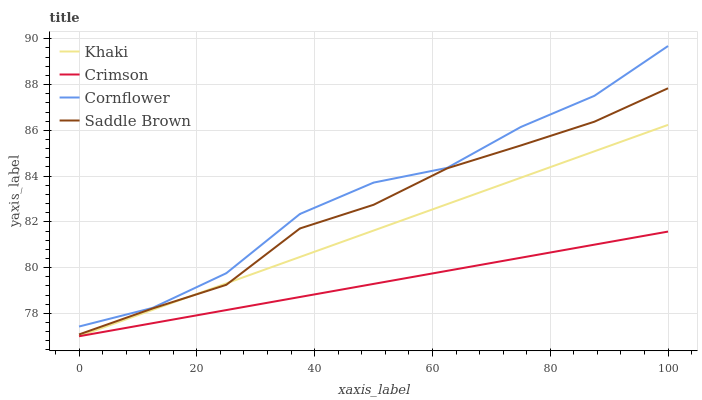Does Crimson have the minimum area under the curve?
Answer yes or no. Yes. Does Cornflower have the maximum area under the curve?
Answer yes or no. Yes. Does Khaki have the minimum area under the curve?
Answer yes or no. No. Does Khaki have the maximum area under the curve?
Answer yes or no. No. Is Khaki the smoothest?
Answer yes or no. Yes. Is Cornflower the roughest?
Answer yes or no. Yes. Is Cornflower the smoothest?
Answer yes or no. No. Is Khaki the roughest?
Answer yes or no. No. Does Crimson have the lowest value?
Answer yes or no. Yes. Does Cornflower have the lowest value?
Answer yes or no. No. Does Cornflower have the highest value?
Answer yes or no. Yes. Does Khaki have the highest value?
Answer yes or no. No. Is Crimson less than Saddle Brown?
Answer yes or no. Yes. Is Cornflower greater than Saddle Brown?
Answer yes or no. Yes. Does Khaki intersect Crimson?
Answer yes or no. Yes. Is Khaki less than Crimson?
Answer yes or no. No. Is Khaki greater than Crimson?
Answer yes or no. No. Does Crimson intersect Saddle Brown?
Answer yes or no. No. 